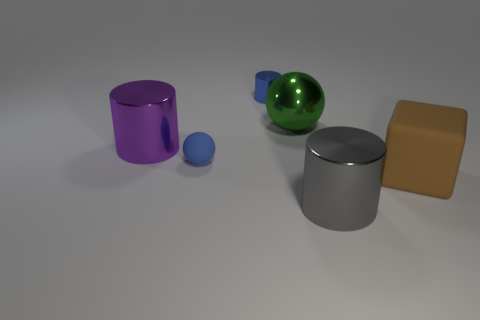Add 1 large purple cylinders. How many objects exist? 7 Subtract all balls. How many objects are left? 4 Subtract 0 brown cylinders. How many objects are left? 6 Subtract all blue matte objects. Subtract all large green balls. How many objects are left? 4 Add 6 blue rubber objects. How many blue rubber objects are left? 7 Add 4 gray cylinders. How many gray cylinders exist? 5 